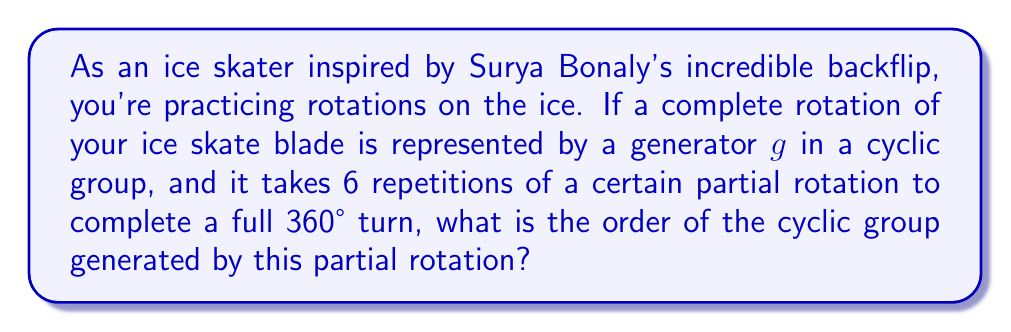Could you help me with this problem? Let's approach this step-by-step:

1) First, we need to understand what the question is asking. We're looking for the order of a cyclic group where the generator represents a partial rotation of the ice skate blade.

2) We're told that it takes 6 repetitions of this partial rotation to complete a full 360° turn. This means that the partial rotation is a 60° turn (360° ÷ 6 = 60°).

3) In group theory, the order of an element is the smallest positive integer $n$ such that $g^n = e$, where $e$ is the identity element. In this case, $e$ would represent a complete 360° rotation (or no rotation at all).

4) Let's call our partial rotation $r$. We know that $r^6 = e$ (6 partial rotations complete a full turn).

5) The cyclic group generated by $r$ is:
   
   $\{e, r, r^2, r^3, r^4, r^5\}$

   Where:
   - $e$ represents 0° or 360° (complete rotation)
   - $r$ represents 60°
   - $r^2$ represents 120°
   - $r^3$ represents 180°
   - $r^4$ represents 240°
   - $r^5$ represents 300°

6) The order of a cyclic group is equal to the order of its generator. In this case, the order of $r$ is 6, as $r^6 = e$ and no smaller positive power of $r$ equals $e$.

Therefore, the order of the cyclic group representing these ice skate blade rotations is 6.
Answer: The order of the cyclic group is 6. 